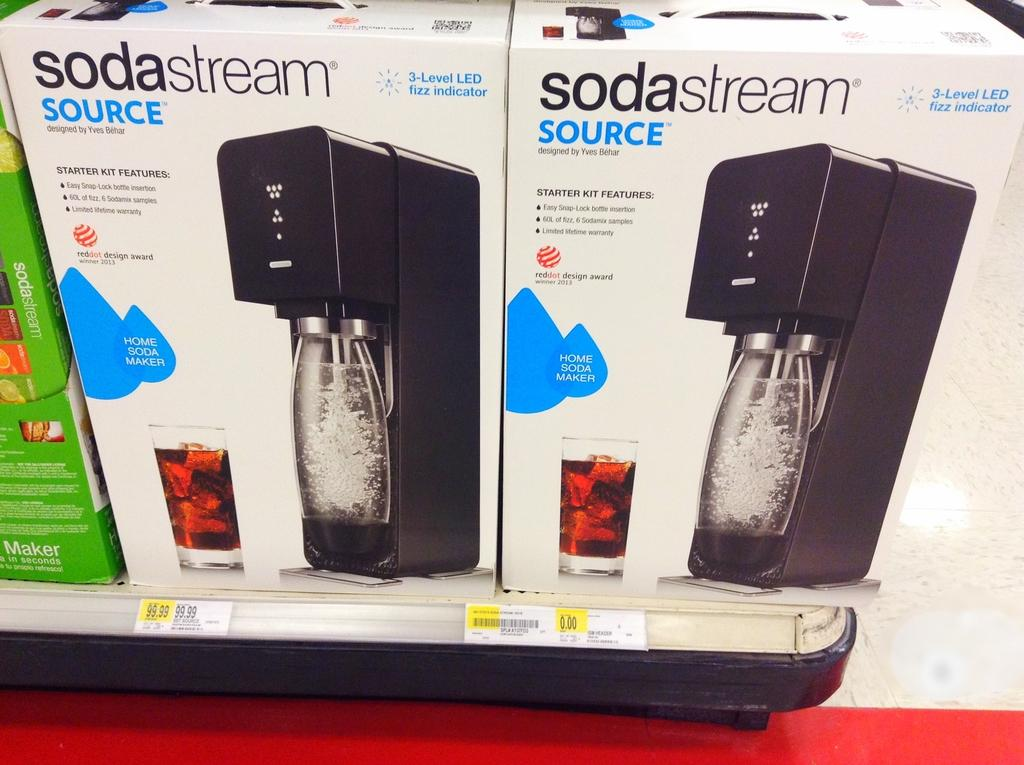<image>
Offer a succinct explanation of the picture presented. A store shelf with new boxes of Soda Stream machines. 